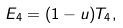<formula> <loc_0><loc_0><loc_500><loc_500>E _ { 4 } = ( 1 - u ) T _ { 4 } ,</formula> 